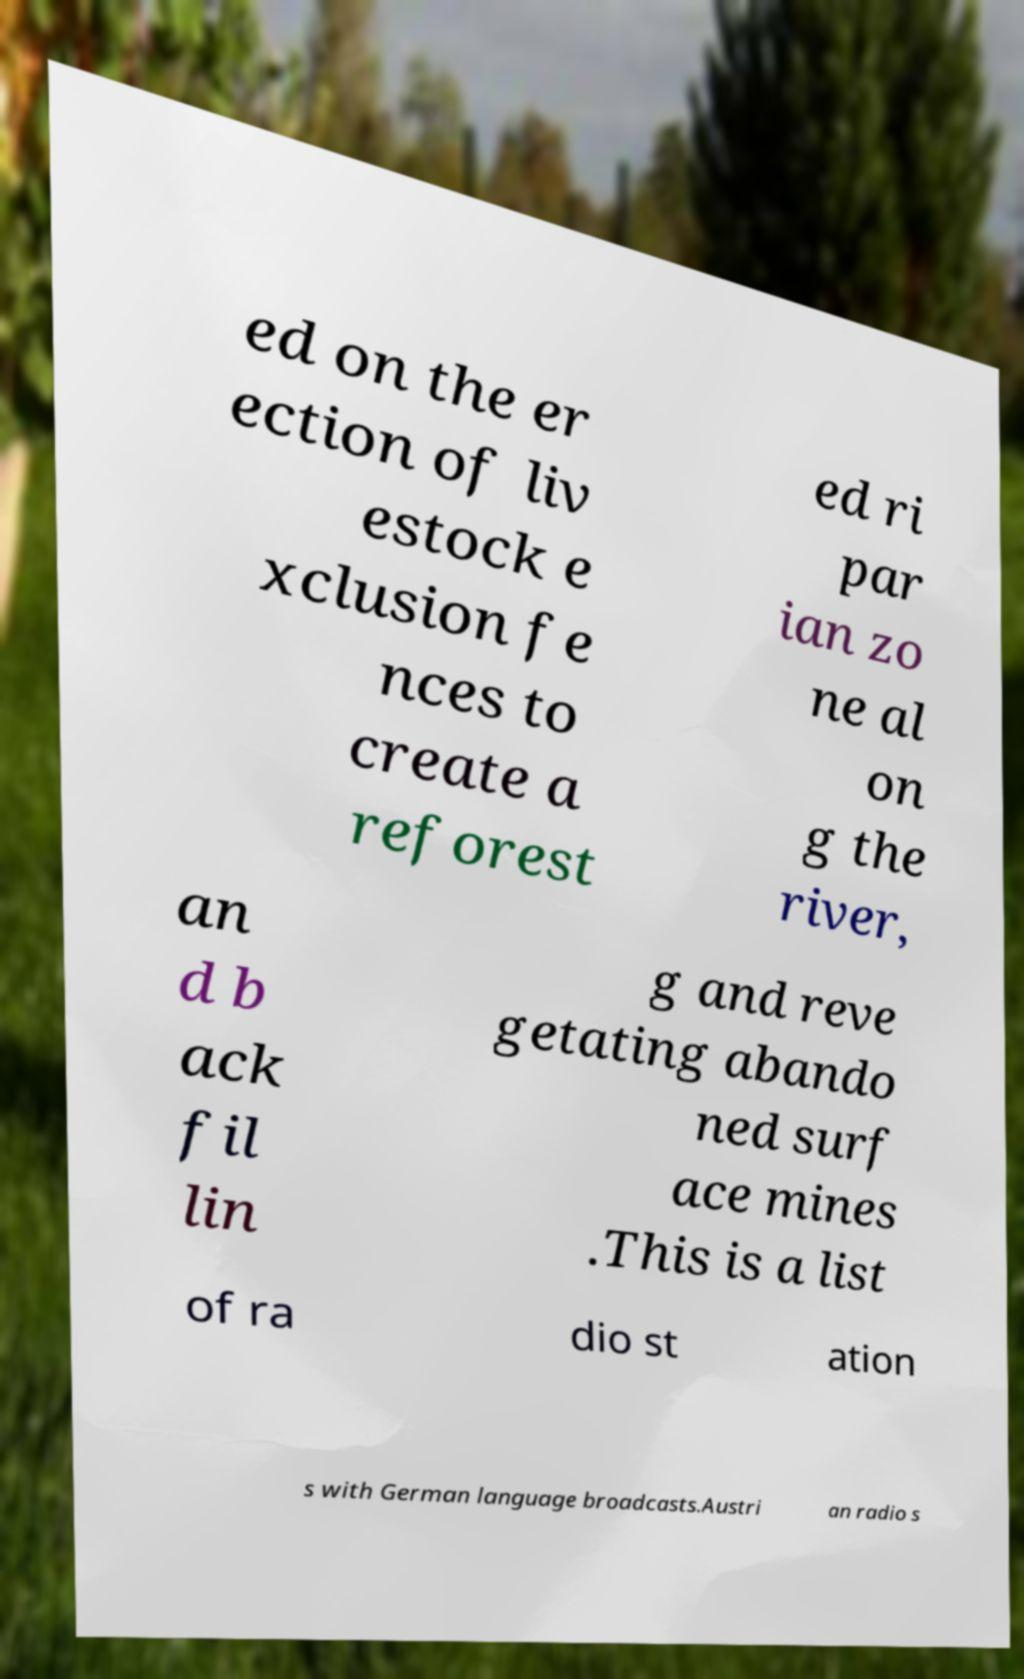Could you assist in decoding the text presented in this image and type it out clearly? ed on the er ection of liv estock e xclusion fe nces to create a reforest ed ri par ian zo ne al on g the river, an d b ack fil lin g and reve getating abando ned surf ace mines .This is a list of ra dio st ation s with German language broadcasts.Austri an radio s 